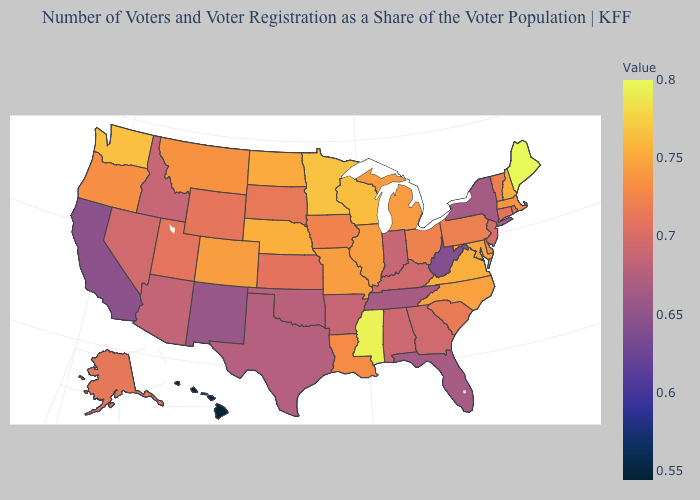Which states have the lowest value in the USA?
Keep it brief. Hawaii. Does Idaho have the highest value in the USA?
Answer briefly. No. Which states hav the highest value in the Northeast?
Concise answer only. Maine. Does Maine have the highest value in the USA?
Concise answer only. Yes. Which states have the highest value in the USA?
Give a very brief answer. Maine. Is the legend a continuous bar?
Write a very short answer. Yes. Among the states that border Nevada , does California have the lowest value?
Quick response, please. Yes. Is the legend a continuous bar?
Answer briefly. Yes. 